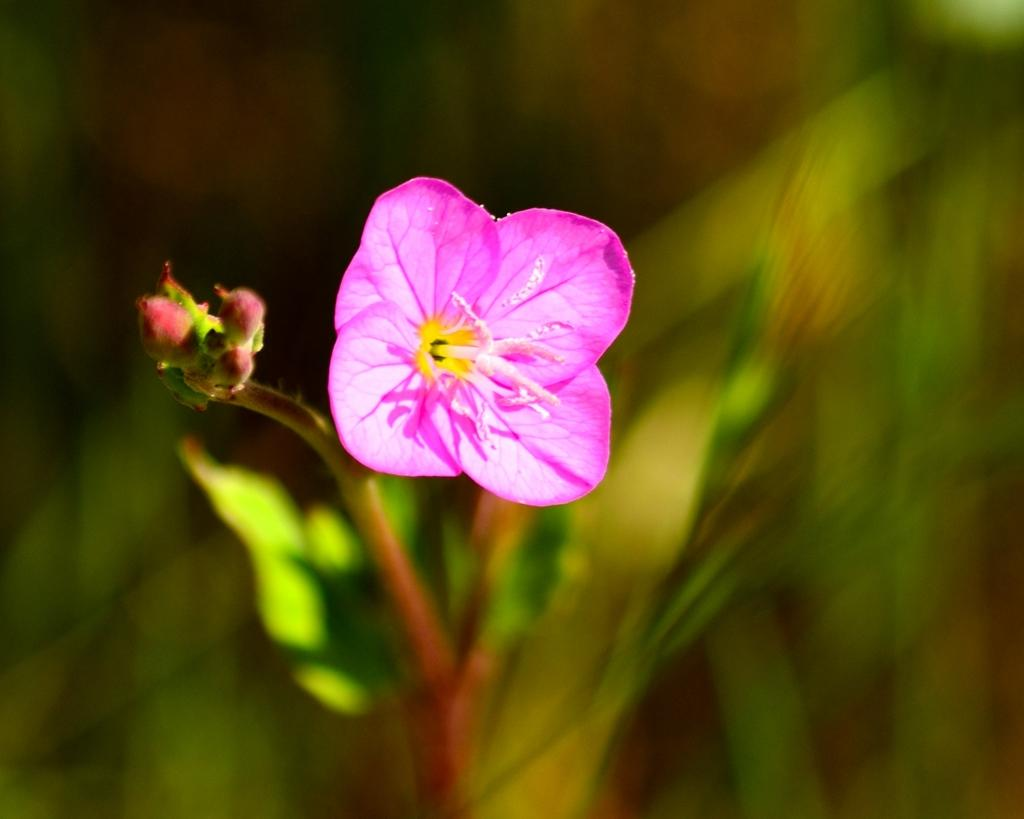What is the main subject of the image? There is a flower in the image. Can you describe the colors of the flower? The flower has pink, yellow, and white colors. What part of the flower is visible besides the petals? The stem of the flower is visible. How would you describe the background of the image? The background of the image is blurred. What love advice can be found in the image? There is no love advice present in the image; it features a flower with pink, yellow, and white colors, a visible stem, and a blurred background. 